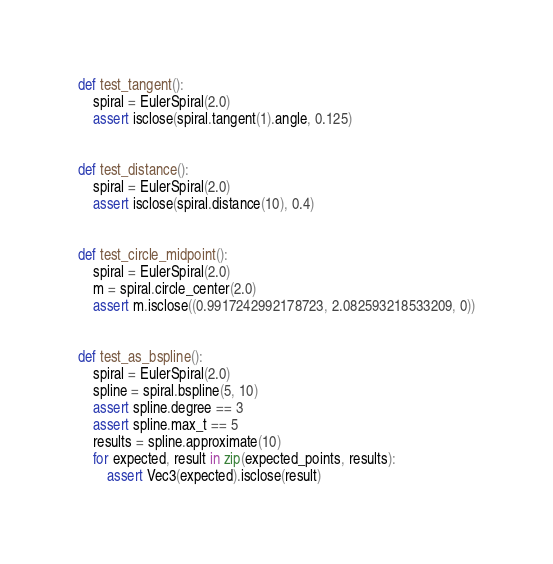<code> <loc_0><loc_0><loc_500><loc_500><_Python_>
def test_tangent():
    spiral = EulerSpiral(2.0)
    assert isclose(spiral.tangent(1).angle, 0.125)


def test_distance():
    spiral = EulerSpiral(2.0)
    assert isclose(spiral.distance(10), 0.4)


def test_circle_midpoint():
    spiral = EulerSpiral(2.0)
    m = spiral.circle_center(2.0)
    assert m.isclose((0.9917242992178723, 2.082593218533209, 0))


def test_as_bspline():
    spiral = EulerSpiral(2.0)
    spline = spiral.bspline(5, 10)
    assert spline.degree == 3
    assert spline.max_t == 5
    results = spline.approximate(10)
    for expected, result in zip(expected_points, results):
        assert Vec3(expected).isclose(result)
</code> 